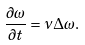<formula> <loc_0><loc_0><loc_500><loc_500>\frac { \partial \omega } { \partial t } = \nu \Delta \omega .</formula> 